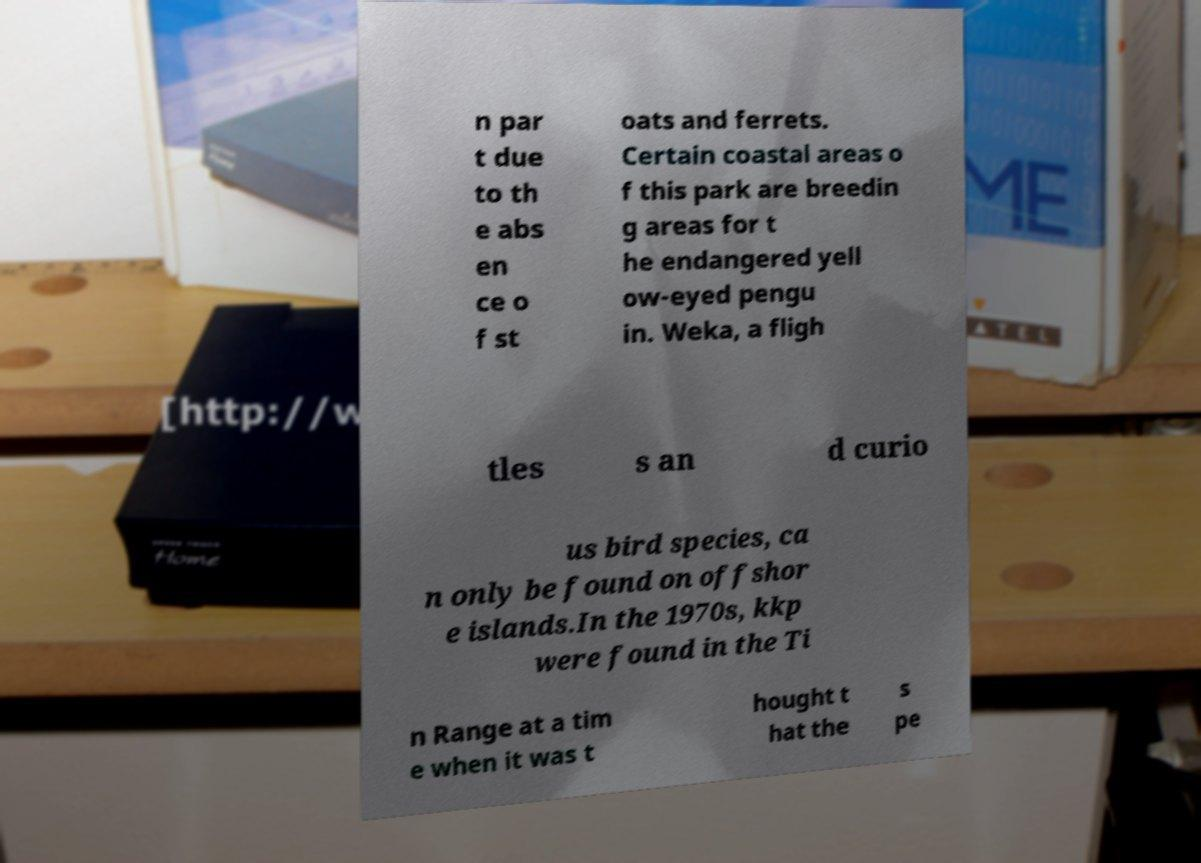Could you extract and type out the text from this image? n par t due to th e abs en ce o f st oats and ferrets. Certain coastal areas o f this park are breedin g areas for t he endangered yell ow-eyed pengu in. Weka, a fligh tles s an d curio us bird species, ca n only be found on offshor e islands.In the 1970s, kkp were found in the Ti n Range at a tim e when it was t hought t hat the s pe 